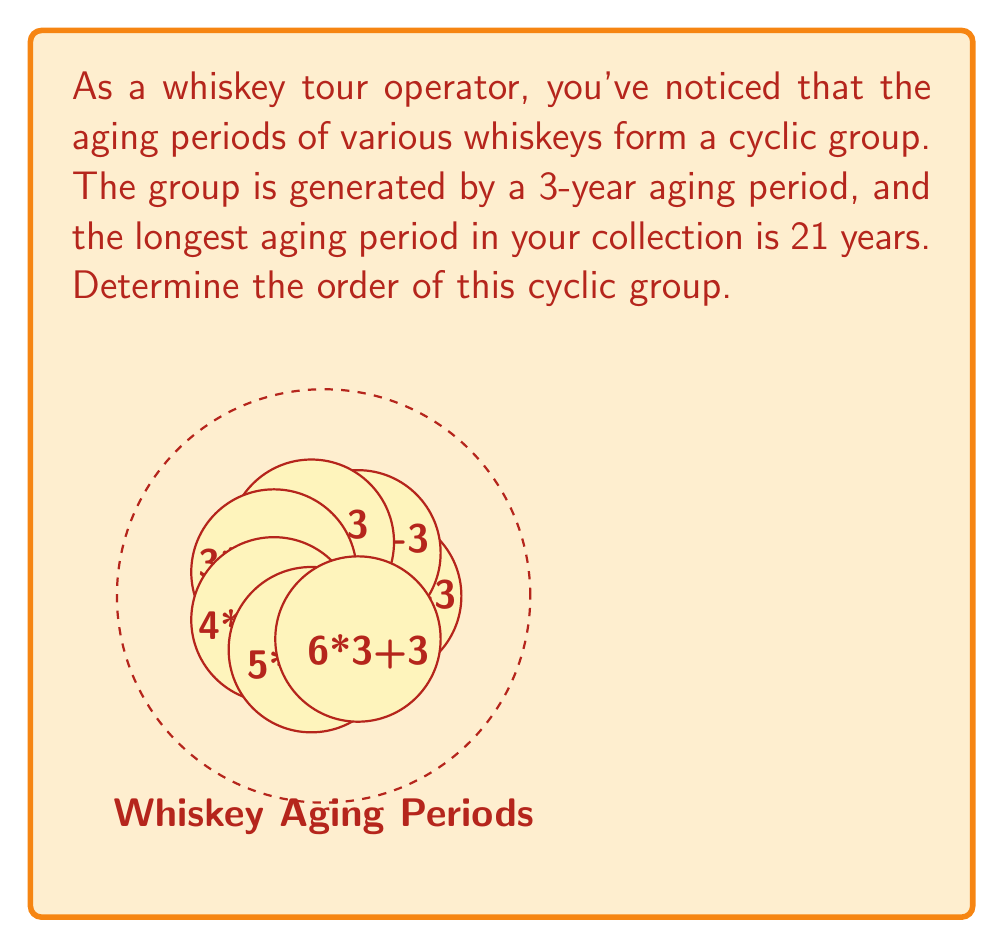Provide a solution to this math problem. Let's approach this step-by-step:

1) In a cyclic group, the order of the group is the smallest positive integer $n$ such that $a^n = e$, where $a$ is the generator and $e$ is the identity element.

2) In this case, the generator is a 3-year aging period. Let's call this element $a$.

3) We need to find the smallest positive integer $n$ such that $3n \equiv 0 \pmod{m}$, where $m$ is the order of the group.

4) We know that the longest aging period is 21 years. This means that $21 \equiv 0 \pmod{m}$.

5) Therefore, $m$ must be a divisor of 21. The divisors of 21 are 1, 3, 7, and 21.

6) We can check each of these:
   - If $m = 1$, then all aging periods would be equivalent, which is not the case.
   - If $m = 3$, then we would only have aging periods of 3, 6, and 9 years, which doesn't include 21 years.
   - If $m = 7$, then we have aging periods of 3, 6, 9, 12, 15, 18, and 21 years, which fits our scenario.
   - If $m = 21$, we would have more aging periods than described in our scenario.

7) Therefore, the order of the cyclic group is 7.

This can be verified mathematically: $3 \cdot 7 = 21 \equiv 0 \pmod{7}$, and 7 is the smallest positive integer with this property.
Answer: 7 